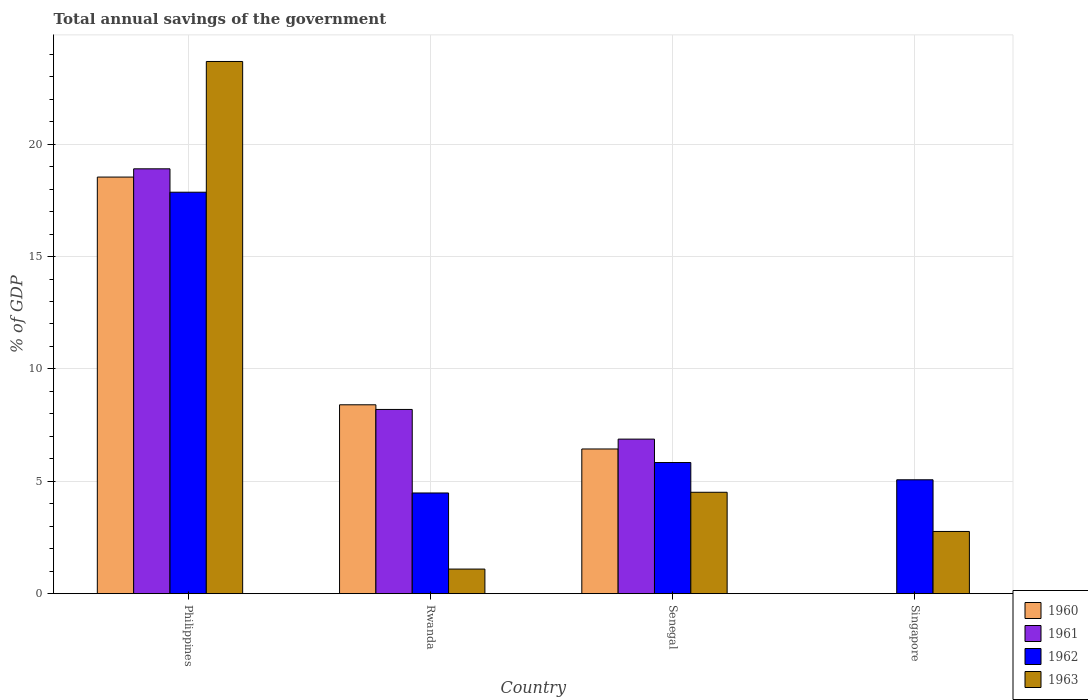Are the number of bars per tick equal to the number of legend labels?
Your response must be concise. No. Are the number of bars on each tick of the X-axis equal?
Provide a short and direct response. No. How many bars are there on the 2nd tick from the right?
Offer a terse response. 4. What is the label of the 4th group of bars from the left?
Your answer should be very brief. Singapore. In how many cases, is the number of bars for a given country not equal to the number of legend labels?
Ensure brevity in your answer.  1. What is the total annual savings of the government in 1961 in Singapore?
Provide a short and direct response. 0. Across all countries, what is the maximum total annual savings of the government in 1962?
Your answer should be very brief. 17.86. Across all countries, what is the minimum total annual savings of the government in 1962?
Offer a very short reply. 4.48. What is the total total annual savings of the government in 1961 in the graph?
Provide a succinct answer. 33.98. What is the difference between the total annual savings of the government in 1962 in Rwanda and that in Senegal?
Provide a succinct answer. -1.35. What is the difference between the total annual savings of the government in 1961 in Philippines and the total annual savings of the government in 1960 in Singapore?
Your answer should be very brief. 18.9. What is the average total annual savings of the government in 1962 per country?
Offer a terse response. 8.31. What is the difference between the total annual savings of the government of/in 1960 and total annual savings of the government of/in 1962 in Senegal?
Ensure brevity in your answer.  0.6. What is the ratio of the total annual savings of the government in 1962 in Senegal to that in Singapore?
Your answer should be compact. 1.15. Is the total annual savings of the government in 1963 in Rwanda less than that in Singapore?
Your answer should be compact. Yes. What is the difference between the highest and the second highest total annual savings of the government in 1963?
Offer a terse response. -1.74. What is the difference between the highest and the lowest total annual savings of the government in 1962?
Ensure brevity in your answer.  13.38. In how many countries, is the total annual savings of the government in 1961 greater than the average total annual savings of the government in 1961 taken over all countries?
Keep it short and to the point. 1. Is it the case that in every country, the sum of the total annual savings of the government in 1962 and total annual savings of the government in 1960 is greater than the sum of total annual savings of the government in 1961 and total annual savings of the government in 1963?
Your response must be concise. No. How many bars are there?
Your response must be concise. 14. Are the values on the major ticks of Y-axis written in scientific E-notation?
Provide a succinct answer. No. Does the graph contain any zero values?
Make the answer very short. Yes. Where does the legend appear in the graph?
Make the answer very short. Bottom right. How many legend labels are there?
Provide a short and direct response. 4. What is the title of the graph?
Your answer should be very brief. Total annual savings of the government. What is the label or title of the X-axis?
Your response must be concise. Country. What is the label or title of the Y-axis?
Make the answer very short. % of GDP. What is the % of GDP of 1960 in Philippines?
Ensure brevity in your answer.  18.54. What is the % of GDP of 1961 in Philippines?
Your answer should be compact. 18.9. What is the % of GDP of 1962 in Philippines?
Give a very brief answer. 17.86. What is the % of GDP in 1963 in Philippines?
Give a very brief answer. 23.68. What is the % of GDP in 1960 in Rwanda?
Provide a short and direct response. 8.4. What is the % of GDP in 1961 in Rwanda?
Make the answer very short. 8.2. What is the % of GDP of 1962 in Rwanda?
Ensure brevity in your answer.  4.48. What is the % of GDP of 1963 in Rwanda?
Your answer should be very brief. 1.09. What is the % of GDP of 1960 in Senegal?
Make the answer very short. 6.44. What is the % of GDP in 1961 in Senegal?
Give a very brief answer. 6.88. What is the % of GDP in 1962 in Senegal?
Give a very brief answer. 5.83. What is the % of GDP in 1963 in Senegal?
Give a very brief answer. 4.51. What is the % of GDP of 1960 in Singapore?
Make the answer very short. 0. What is the % of GDP in 1961 in Singapore?
Make the answer very short. 0. What is the % of GDP of 1962 in Singapore?
Your answer should be very brief. 5.07. What is the % of GDP of 1963 in Singapore?
Provide a succinct answer. 2.77. Across all countries, what is the maximum % of GDP of 1960?
Make the answer very short. 18.54. Across all countries, what is the maximum % of GDP of 1961?
Your answer should be very brief. 18.9. Across all countries, what is the maximum % of GDP in 1962?
Give a very brief answer. 17.86. Across all countries, what is the maximum % of GDP in 1963?
Ensure brevity in your answer.  23.68. Across all countries, what is the minimum % of GDP in 1962?
Ensure brevity in your answer.  4.48. Across all countries, what is the minimum % of GDP in 1963?
Make the answer very short. 1.09. What is the total % of GDP of 1960 in the graph?
Provide a short and direct response. 33.38. What is the total % of GDP in 1961 in the graph?
Provide a succinct answer. 33.98. What is the total % of GDP of 1962 in the graph?
Provide a succinct answer. 33.24. What is the total % of GDP in 1963 in the graph?
Offer a very short reply. 32.05. What is the difference between the % of GDP of 1960 in Philippines and that in Rwanda?
Ensure brevity in your answer.  10.13. What is the difference between the % of GDP of 1961 in Philippines and that in Rwanda?
Keep it short and to the point. 10.71. What is the difference between the % of GDP in 1962 in Philippines and that in Rwanda?
Make the answer very short. 13.38. What is the difference between the % of GDP of 1963 in Philippines and that in Rwanda?
Provide a short and direct response. 22.58. What is the difference between the % of GDP in 1960 in Philippines and that in Senegal?
Keep it short and to the point. 12.1. What is the difference between the % of GDP of 1961 in Philippines and that in Senegal?
Make the answer very short. 12.03. What is the difference between the % of GDP in 1962 in Philippines and that in Senegal?
Give a very brief answer. 12.03. What is the difference between the % of GDP in 1963 in Philippines and that in Senegal?
Provide a succinct answer. 19.17. What is the difference between the % of GDP in 1962 in Philippines and that in Singapore?
Give a very brief answer. 12.79. What is the difference between the % of GDP of 1963 in Philippines and that in Singapore?
Offer a terse response. 20.91. What is the difference between the % of GDP in 1960 in Rwanda and that in Senegal?
Offer a very short reply. 1.97. What is the difference between the % of GDP in 1961 in Rwanda and that in Senegal?
Provide a succinct answer. 1.32. What is the difference between the % of GDP of 1962 in Rwanda and that in Senegal?
Your answer should be very brief. -1.35. What is the difference between the % of GDP of 1963 in Rwanda and that in Senegal?
Give a very brief answer. -3.42. What is the difference between the % of GDP of 1962 in Rwanda and that in Singapore?
Give a very brief answer. -0.59. What is the difference between the % of GDP in 1963 in Rwanda and that in Singapore?
Offer a terse response. -1.67. What is the difference between the % of GDP of 1962 in Senegal and that in Singapore?
Provide a short and direct response. 0.77. What is the difference between the % of GDP in 1963 in Senegal and that in Singapore?
Offer a very short reply. 1.74. What is the difference between the % of GDP in 1960 in Philippines and the % of GDP in 1961 in Rwanda?
Ensure brevity in your answer.  10.34. What is the difference between the % of GDP in 1960 in Philippines and the % of GDP in 1962 in Rwanda?
Give a very brief answer. 14.06. What is the difference between the % of GDP in 1960 in Philippines and the % of GDP in 1963 in Rwanda?
Offer a very short reply. 17.44. What is the difference between the % of GDP in 1961 in Philippines and the % of GDP in 1962 in Rwanda?
Your answer should be very brief. 14.42. What is the difference between the % of GDP of 1961 in Philippines and the % of GDP of 1963 in Rwanda?
Provide a succinct answer. 17.81. What is the difference between the % of GDP in 1962 in Philippines and the % of GDP in 1963 in Rwanda?
Offer a terse response. 16.77. What is the difference between the % of GDP in 1960 in Philippines and the % of GDP in 1961 in Senegal?
Keep it short and to the point. 11.66. What is the difference between the % of GDP of 1960 in Philippines and the % of GDP of 1962 in Senegal?
Your answer should be very brief. 12.7. What is the difference between the % of GDP of 1960 in Philippines and the % of GDP of 1963 in Senegal?
Ensure brevity in your answer.  14.03. What is the difference between the % of GDP of 1961 in Philippines and the % of GDP of 1962 in Senegal?
Your answer should be compact. 13.07. What is the difference between the % of GDP of 1961 in Philippines and the % of GDP of 1963 in Senegal?
Your answer should be very brief. 14.39. What is the difference between the % of GDP of 1962 in Philippines and the % of GDP of 1963 in Senegal?
Provide a succinct answer. 13.35. What is the difference between the % of GDP in 1960 in Philippines and the % of GDP in 1962 in Singapore?
Your response must be concise. 13.47. What is the difference between the % of GDP in 1960 in Philippines and the % of GDP in 1963 in Singapore?
Provide a short and direct response. 15.77. What is the difference between the % of GDP in 1961 in Philippines and the % of GDP in 1962 in Singapore?
Make the answer very short. 13.84. What is the difference between the % of GDP of 1961 in Philippines and the % of GDP of 1963 in Singapore?
Your answer should be very brief. 16.14. What is the difference between the % of GDP in 1962 in Philippines and the % of GDP in 1963 in Singapore?
Offer a terse response. 15.09. What is the difference between the % of GDP of 1960 in Rwanda and the % of GDP of 1961 in Senegal?
Ensure brevity in your answer.  1.53. What is the difference between the % of GDP of 1960 in Rwanda and the % of GDP of 1962 in Senegal?
Give a very brief answer. 2.57. What is the difference between the % of GDP of 1960 in Rwanda and the % of GDP of 1963 in Senegal?
Provide a short and direct response. 3.89. What is the difference between the % of GDP in 1961 in Rwanda and the % of GDP in 1962 in Senegal?
Provide a succinct answer. 2.36. What is the difference between the % of GDP of 1961 in Rwanda and the % of GDP of 1963 in Senegal?
Make the answer very short. 3.69. What is the difference between the % of GDP of 1962 in Rwanda and the % of GDP of 1963 in Senegal?
Keep it short and to the point. -0.03. What is the difference between the % of GDP in 1960 in Rwanda and the % of GDP in 1962 in Singapore?
Your answer should be compact. 3.34. What is the difference between the % of GDP in 1960 in Rwanda and the % of GDP in 1963 in Singapore?
Your response must be concise. 5.64. What is the difference between the % of GDP of 1961 in Rwanda and the % of GDP of 1962 in Singapore?
Your answer should be compact. 3.13. What is the difference between the % of GDP of 1961 in Rwanda and the % of GDP of 1963 in Singapore?
Keep it short and to the point. 5.43. What is the difference between the % of GDP in 1962 in Rwanda and the % of GDP in 1963 in Singapore?
Offer a terse response. 1.71. What is the difference between the % of GDP in 1960 in Senegal and the % of GDP in 1962 in Singapore?
Give a very brief answer. 1.37. What is the difference between the % of GDP in 1960 in Senegal and the % of GDP in 1963 in Singapore?
Your response must be concise. 3.67. What is the difference between the % of GDP of 1961 in Senegal and the % of GDP of 1962 in Singapore?
Ensure brevity in your answer.  1.81. What is the difference between the % of GDP of 1961 in Senegal and the % of GDP of 1963 in Singapore?
Your response must be concise. 4.11. What is the difference between the % of GDP of 1962 in Senegal and the % of GDP of 1963 in Singapore?
Provide a succinct answer. 3.07. What is the average % of GDP in 1960 per country?
Your answer should be very brief. 8.34. What is the average % of GDP of 1961 per country?
Offer a very short reply. 8.49. What is the average % of GDP of 1962 per country?
Your response must be concise. 8.31. What is the average % of GDP of 1963 per country?
Provide a short and direct response. 8.01. What is the difference between the % of GDP of 1960 and % of GDP of 1961 in Philippines?
Your answer should be compact. -0.37. What is the difference between the % of GDP in 1960 and % of GDP in 1962 in Philippines?
Make the answer very short. 0.67. What is the difference between the % of GDP in 1960 and % of GDP in 1963 in Philippines?
Ensure brevity in your answer.  -5.14. What is the difference between the % of GDP in 1961 and % of GDP in 1962 in Philippines?
Give a very brief answer. 1.04. What is the difference between the % of GDP of 1961 and % of GDP of 1963 in Philippines?
Your answer should be very brief. -4.78. What is the difference between the % of GDP of 1962 and % of GDP of 1963 in Philippines?
Your answer should be compact. -5.82. What is the difference between the % of GDP of 1960 and % of GDP of 1961 in Rwanda?
Your answer should be compact. 0.21. What is the difference between the % of GDP in 1960 and % of GDP in 1962 in Rwanda?
Give a very brief answer. 3.92. What is the difference between the % of GDP of 1960 and % of GDP of 1963 in Rwanda?
Ensure brevity in your answer.  7.31. What is the difference between the % of GDP of 1961 and % of GDP of 1962 in Rwanda?
Provide a short and direct response. 3.72. What is the difference between the % of GDP in 1961 and % of GDP in 1963 in Rwanda?
Offer a very short reply. 7.1. What is the difference between the % of GDP in 1962 and % of GDP in 1963 in Rwanda?
Your response must be concise. 3.39. What is the difference between the % of GDP of 1960 and % of GDP of 1961 in Senegal?
Your answer should be compact. -0.44. What is the difference between the % of GDP in 1960 and % of GDP in 1962 in Senegal?
Offer a terse response. 0.6. What is the difference between the % of GDP of 1960 and % of GDP of 1963 in Senegal?
Offer a very short reply. 1.93. What is the difference between the % of GDP of 1961 and % of GDP of 1962 in Senegal?
Ensure brevity in your answer.  1.04. What is the difference between the % of GDP in 1961 and % of GDP in 1963 in Senegal?
Your answer should be compact. 2.37. What is the difference between the % of GDP in 1962 and % of GDP in 1963 in Senegal?
Your answer should be very brief. 1.32. What is the difference between the % of GDP of 1962 and % of GDP of 1963 in Singapore?
Make the answer very short. 2.3. What is the ratio of the % of GDP in 1960 in Philippines to that in Rwanda?
Provide a short and direct response. 2.21. What is the ratio of the % of GDP in 1961 in Philippines to that in Rwanda?
Your answer should be very brief. 2.31. What is the ratio of the % of GDP in 1962 in Philippines to that in Rwanda?
Your response must be concise. 3.99. What is the ratio of the % of GDP in 1963 in Philippines to that in Rwanda?
Keep it short and to the point. 21.65. What is the ratio of the % of GDP of 1960 in Philippines to that in Senegal?
Your answer should be very brief. 2.88. What is the ratio of the % of GDP of 1961 in Philippines to that in Senegal?
Keep it short and to the point. 2.75. What is the ratio of the % of GDP of 1962 in Philippines to that in Senegal?
Give a very brief answer. 3.06. What is the ratio of the % of GDP in 1963 in Philippines to that in Senegal?
Provide a succinct answer. 5.25. What is the ratio of the % of GDP in 1962 in Philippines to that in Singapore?
Offer a terse response. 3.53. What is the ratio of the % of GDP in 1963 in Philippines to that in Singapore?
Provide a short and direct response. 8.56. What is the ratio of the % of GDP in 1960 in Rwanda to that in Senegal?
Your response must be concise. 1.31. What is the ratio of the % of GDP in 1961 in Rwanda to that in Senegal?
Ensure brevity in your answer.  1.19. What is the ratio of the % of GDP in 1962 in Rwanda to that in Senegal?
Your response must be concise. 0.77. What is the ratio of the % of GDP in 1963 in Rwanda to that in Senegal?
Make the answer very short. 0.24. What is the ratio of the % of GDP in 1962 in Rwanda to that in Singapore?
Ensure brevity in your answer.  0.88. What is the ratio of the % of GDP of 1963 in Rwanda to that in Singapore?
Offer a very short reply. 0.4. What is the ratio of the % of GDP of 1962 in Senegal to that in Singapore?
Your answer should be compact. 1.15. What is the ratio of the % of GDP in 1963 in Senegal to that in Singapore?
Offer a very short reply. 1.63. What is the difference between the highest and the second highest % of GDP in 1960?
Give a very brief answer. 10.13. What is the difference between the highest and the second highest % of GDP in 1961?
Your answer should be compact. 10.71. What is the difference between the highest and the second highest % of GDP of 1962?
Offer a terse response. 12.03. What is the difference between the highest and the second highest % of GDP in 1963?
Provide a succinct answer. 19.17. What is the difference between the highest and the lowest % of GDP in 1960?
Give a very brief answer. 18.54. What is the difference between the highest and the lowest % of GDP in 1961?
Give a very brief answer. 18.9. What is the difference between the highest and the lowest % of GDP of 1962?
Your answer should be compact. 13.38. What is the difference between the highest and the lowest % of GDP of 1963?
Your response must be concise. 22.58. 